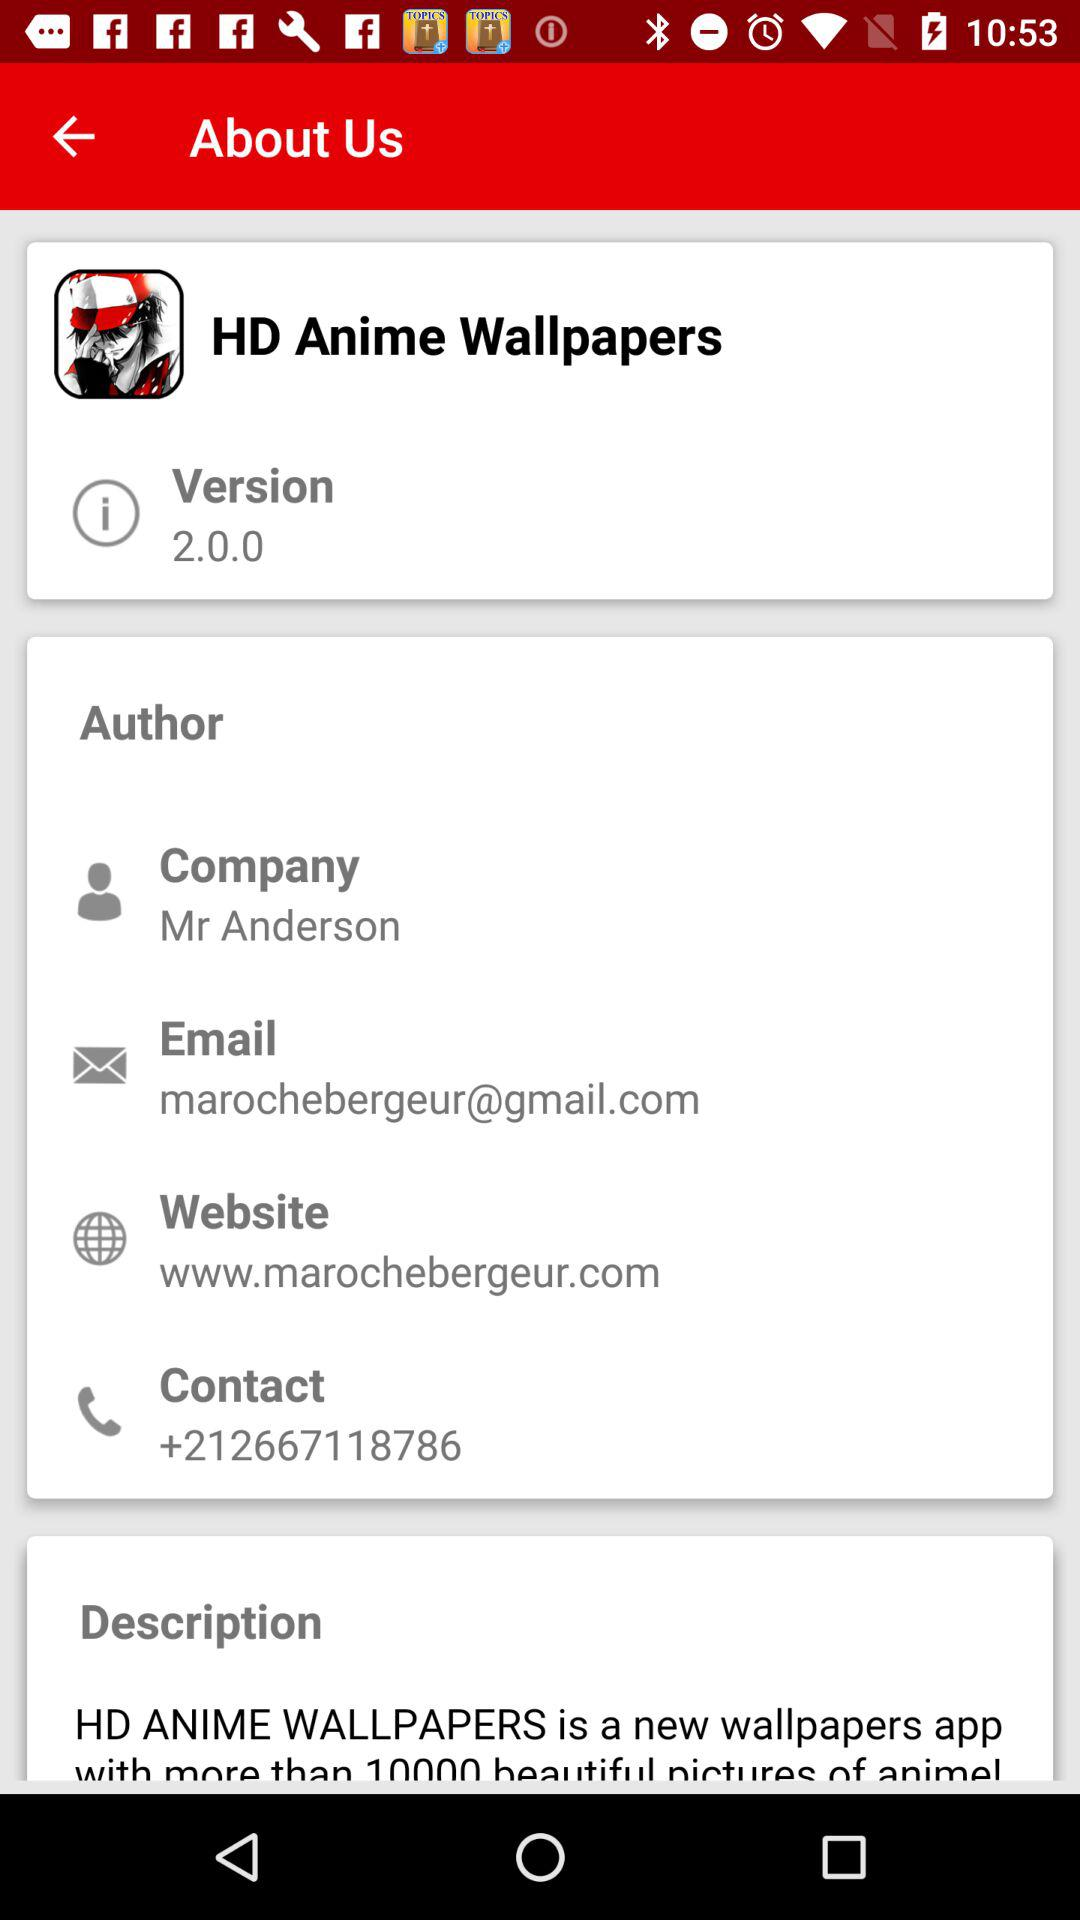What is the name of the application? The name of the application is "HD Anime Wallpapers". 